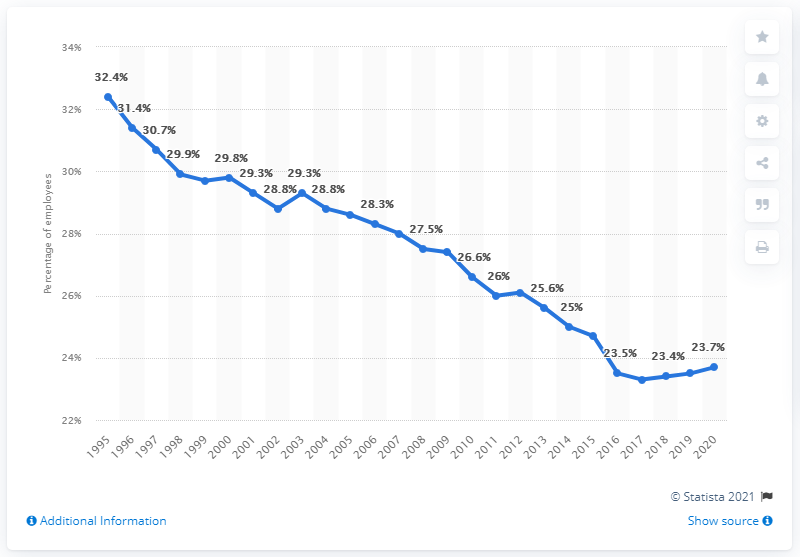Give some essential details in this illustration. In 2020, 23.7% of employees in the UK were members of a trade union. In 1995, the share of employees who were members of a trade union was 32.4 percent. 